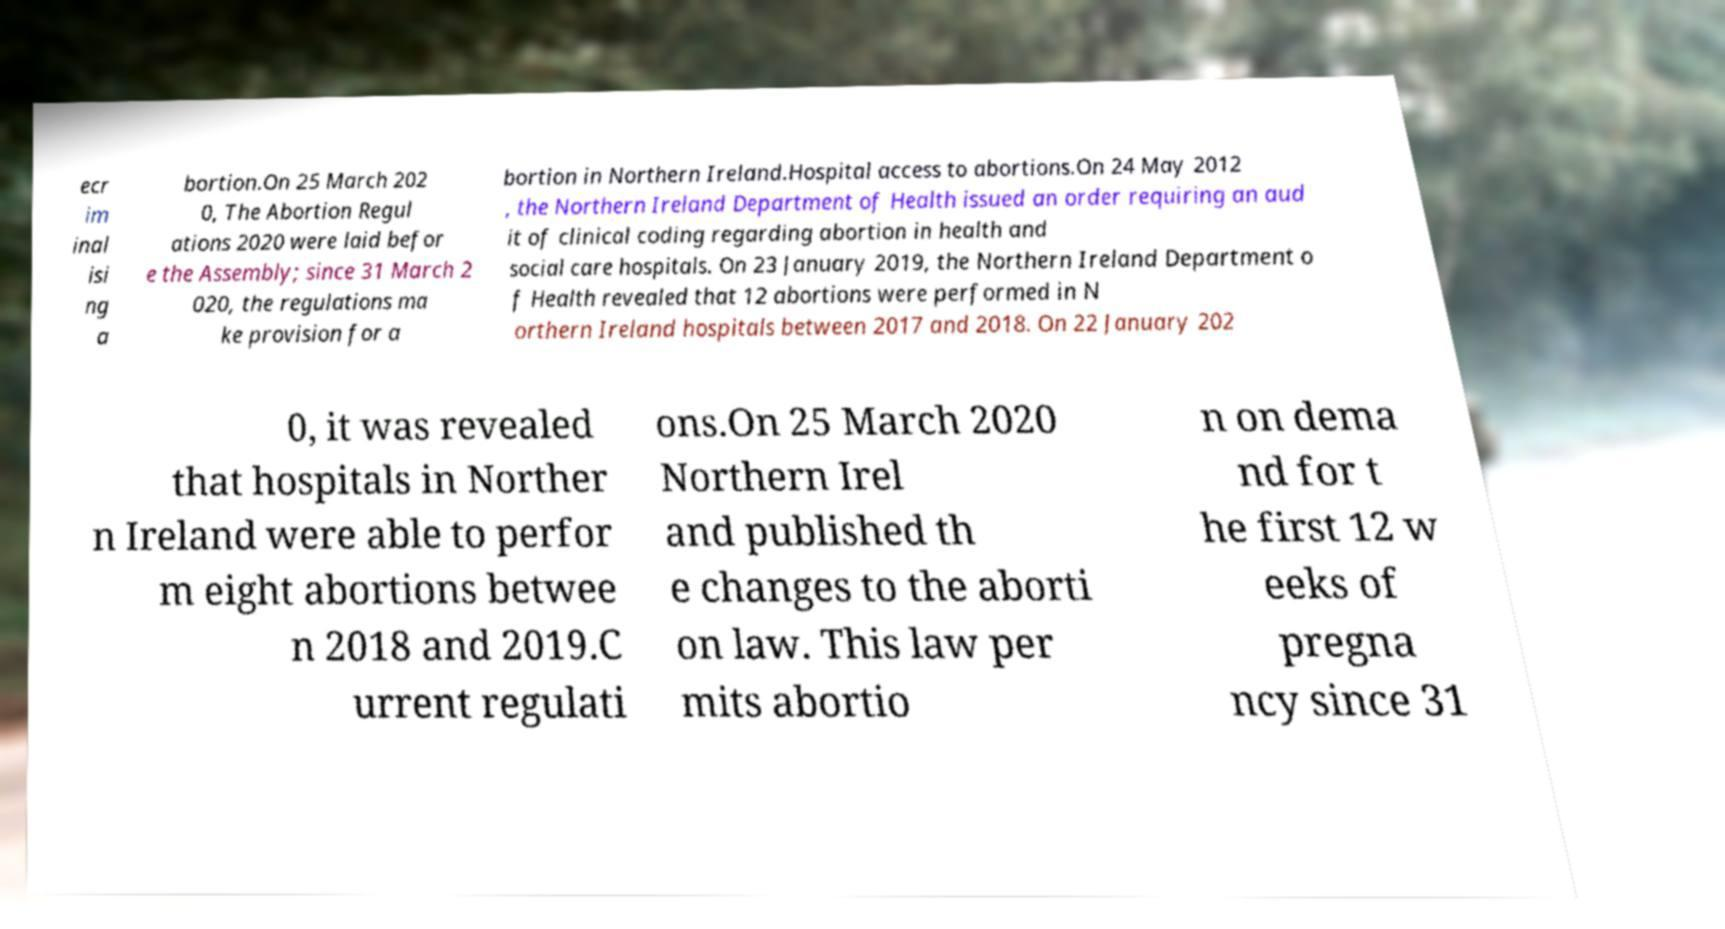Can you accurately transcribe the text from the provided image for me? ecr im inal isi ng a bortion.On 25 March 202 0, The Abortion Regul ations 2020 were laid befor e the Assembly; since 31 March 2 020, the regulations ma ke provision for a bortion in Northern Ireland.Hospital access to abortions.On 24 May 2012 , the Northern Ireland Department of Health issued an order requiring an aud it of clinical coding regarding abortion in health and social care hospitals. On 23 January 2019, the Northern Ireland Department o f Health revealed that 12 abortions were performed in N orthern Ireland hospitals between 2017 and 2018. On 22 January 202 0, it was revealed that hospitals in Norther n Ireland were able to perfor m eight abortions betwee n 2018 and 2019.C urrent regulati ons.On 25 March 2020 Northern Irel and published th e changes to the aborti on law. This law per mits abortio n on dema nd for t he first 12 w eeks of pregna ncy since 31 